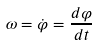<formula> <loc_0><loc_0><loc_500><loc_500>\omega = \dot { \varphi } = \frac { d \varphi } { d t }</formula> 